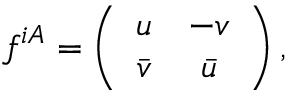<formula> <loc_0><loc_0><loc_500><loc_500>f ^ { i A } = \left ( \begin{array} { c c } { u } & { - v } \\ { { \bar { v } } } & { { \bar { u } } } \end{array} \right ) ,</formula> 